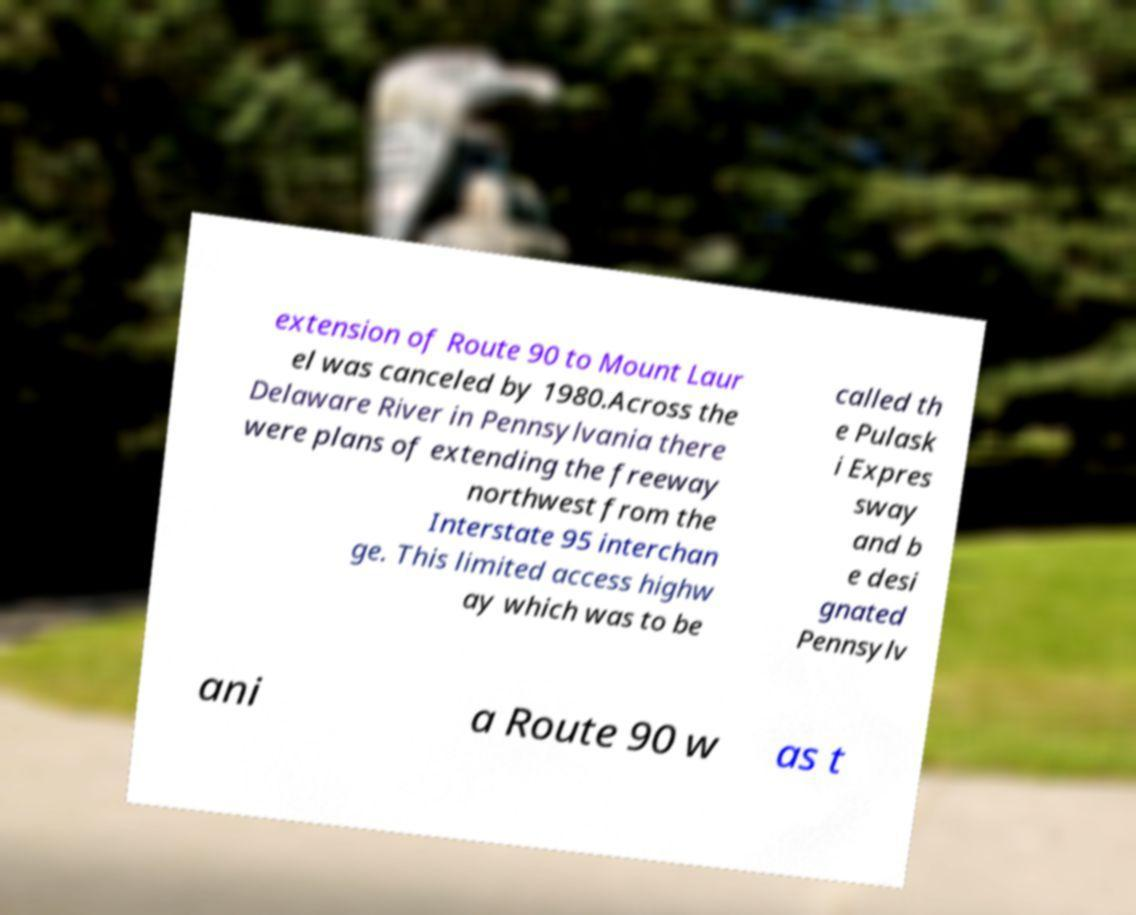There's text embedded in this image that I need extracted. Can you transcribe it verbatim? extension of Route 90 to Mount Laur el was canceled by 1980.Across the Delaware River in Pennsylvania there were plans of extending the freeway northwest from the Interstate 95 interchan ge. This limited access highw ay which was to be called th e Pulask i Expres sway and b e desi gnated Pennsylv ani a Route 90 w as t 